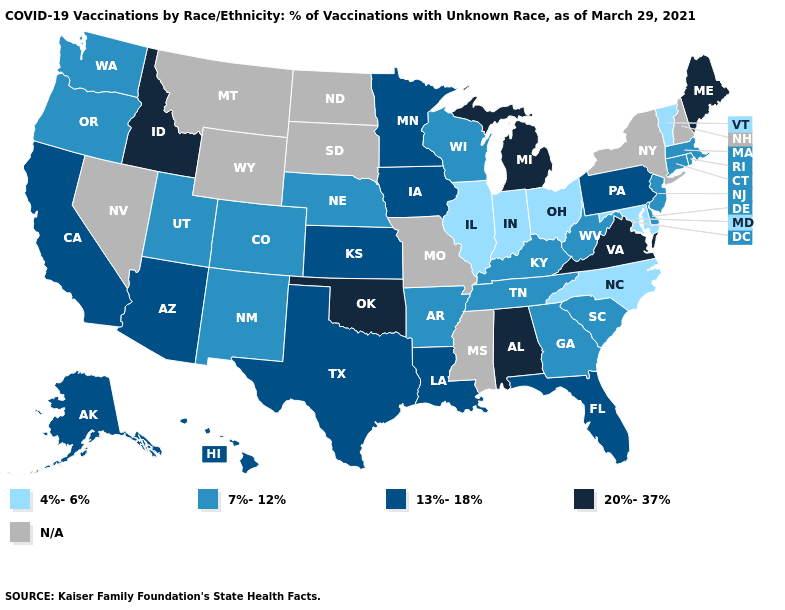Name the states that have a value in the range 13%-18%?
Be succinct. Alaska, Arizona, California, Florida, Hawaii, Iowa, Kansas, Louisiana, Minnesota, Pennsylvania, Texas. Does Illinois have the lowest value in the MidWest?
Quick response, please. Yes. Among the states that border Kansas , does Colorado have the highest value?
Short answer required. No. What is the lowest value in the South?
Write a very short answer. 4%-6%. Which states have the highest value in the USA?
Quick response, please. Alabama, Idaho, Maine, Michigan, Oklahoma, Virginia. What is the highest value in the USA?
Answer briefly. 20%-37%. What is the value of Georgia?
Be succinct. 7%-12%. What is the lowest value in the South?
Answer briefly. 4%-6%. Name the states that have a value in the range 7%-12%?
Keep it brief. Arkansas, Colorado, Connecticut, Delaware, Georgia, Kentucky, Massachusetts, Nebraska, New Jersey, New Mexico, Oregon, Rhode Island, South Carolina, Tennessee, Utah, Washington, West Virginia, Wisconsin. Does Alabama have the highest value in the USA?
Keep it brief. Yes. Does Vermont have the lowest value in the Northeast?
Write a very short answer. Yes. What is the highest value in states that border Delaware?
Keep it brief. 13%-18%. Name the states that have a value in the range 20%-37%?
Give a very brief answer. Alabama, Idaho, Maine, Michigan, Oklahoma, Virginia. 